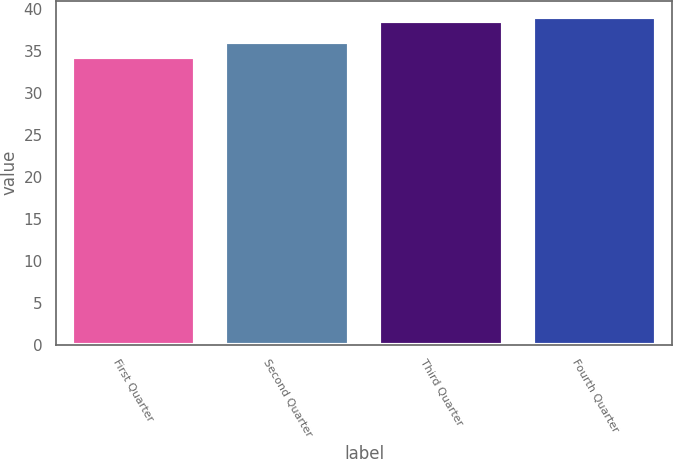Convert chart. <chart><loc_0><loc_0><loc_500><loc_500><bar_chart><fcel>First Quarter<fcel>Second Quarter<fcel>Third Quarter<fcel>Fourth Quarter<nl><fcel>34.28<fcel>36.14<fcel>38.59<fcel>39.06<nl></chart> 